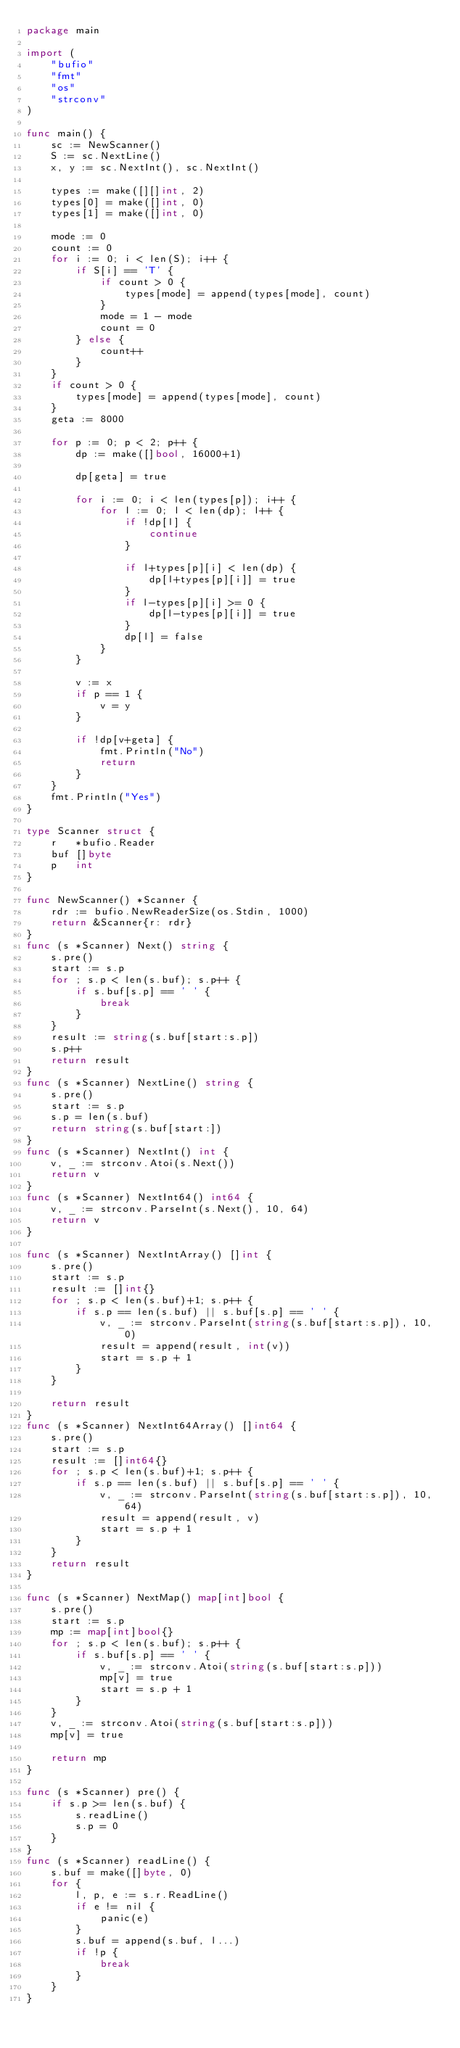Convert code to text. <code><loc_0><loc_0><loc_500><loc_500><_Go_>package main

import (
	"bufio"
	"fmt"
	"os"
	"strconv"
)

func main() {
	sc := NewScanner()
	S := sc.NextLine()
	x, y := sc.NextInt(), sc.NextInt()

	types := make([][]int, 2)
	types[0] = make([]int, 0)
	types[1] = make([]int, 0)

	mode := 0
	count := 0
	for i := 0; i < len(S); i++ {
		if S[i] == 'T' {
			if count > 0 {
				types[mode] = append(types[mode], count)
			}
			mode = 1 - mode
			count = 0
		} else {
			count++
		}
	}
	if count > 0 {
		types[mode] = append(types[mode], count)
	}
	geta := 8000

	for p := 0; p < 2; p++ {
		dp := make([]bool, 16000+1)

		dp[geta] = true

		for i := 0; i < len(types[p]); i++ {
			for l := 0; l < len(dp); l++ {
				if !dp[l] {
					continue
				}

				if l+types[p][i] < len(dp) {
					dp[l+types[p][i]] = true
				}
				if l-types[p][i] >= 0 {
					dp[l-types[p][i]] = true
				}
				dp[l] = false
			}
		}

		v := x
		if p == 1 {
			v = y
		}

		if !dp[v+geta] {
			fmt.Println("No")
			return
		}
	}
	fmt.Println("Yes")
}

type Scanner struct {
	r   *bufio.Reader
	buf []byte
	p   int
}

func NewScanner() *Scanner {
	rdr := bufio.NewReaderSize(os.Stdin, 1000)
	return &Scanner{r: rdr}
}
func (s *Scanner) Next() string {
	s.pre()
	start := s.p
	for ; s.p < len(s.buf); s.p++ {
		if s.buf[s.p] == ' ' {
			break
		}
	}
	result := string(s.buf[start:s.p])
	s.p++
	return result
}
func (s *Scanner) NextLine() string {
	s.pre()
	start := s.p
	s.p = len(s.buf)
	return string(s.buf[start:])
}
func (s *Scanner) NextInt() int {
	v, _ := strconv.Atoi(s.Next())
	return v
}
func (s *Scanner) NextInt64() int64 {
	v, _ := strconv.ParseInt(s.Next(), 10, 64)
	return v
}

func (s *Scanner) NextIntArray() []int {
	s.pre()
	start := s.p
	result := []int{}
	for ; s.p < len(s.buf)+1; s.p++ {
		if s.p == len(s.buf) || s.buf[s.p] == ' ' {
			v, _ := strconv.ParseInt(string(s.buf[start:s.p]), 10, 0)
			result = append(result, int(v))
			start = s.p + 1
		}
	}

	return result
}
func (s *Scanner) NextInt64Array() []int64 {
	s.pre()
	start := s.p
	result := []int64{}
	for ; s.p < len(s.buf)+1; s.p++ {
		if s.p == len(s.buf) || s.buf[s.p] == ' ' {
			v, _ := strconv.ParseInt(string(s.buf[start:s.p]), 10, 64)
			result = append(result, v)
			start = s.p + 1
		}
	}
	return result
}

func (s *Scanner) NextMap() map[int]bool {
	s.pre()
	start := s.p
	mp := map[int]bool{}
	for ; s.p < len(s.buf); s.p++ {
		if s.buf[s.p] == ' ' {
			v, _ := strconv.Atoi(string(s.buf[start:s.p]))
			mp[v] = true
			start = s.p + 1
		}
	}
	v, _ := strconv.Atoi(string(s.buf[start:s.p]))
	mp[v] = true

	return mp
}

func (s *Scanner) pre() {
	if s.p >= len(s.buf) {
		s.readLine()
		s.p = 0
	}
}
func (s *Scanner) readLine() {
	s.buf = make([]byte, 0)
	for {
		l, p, e := s.r.ReadLine()
		if e != nil {
			panic(e)
		}
		s.buf = append(s.buf, l...)
		if !p {
			break
		}
	}
}
</code> 